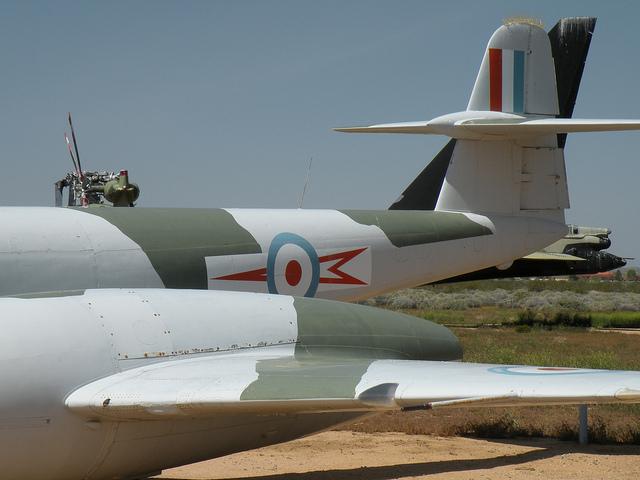Is the plane flying?
Answer briefly. No. Is this plane safe?
Quick response, please. Yes. What is the picture on the plane?
Be succinct. Bullseye with arrow behind it. 